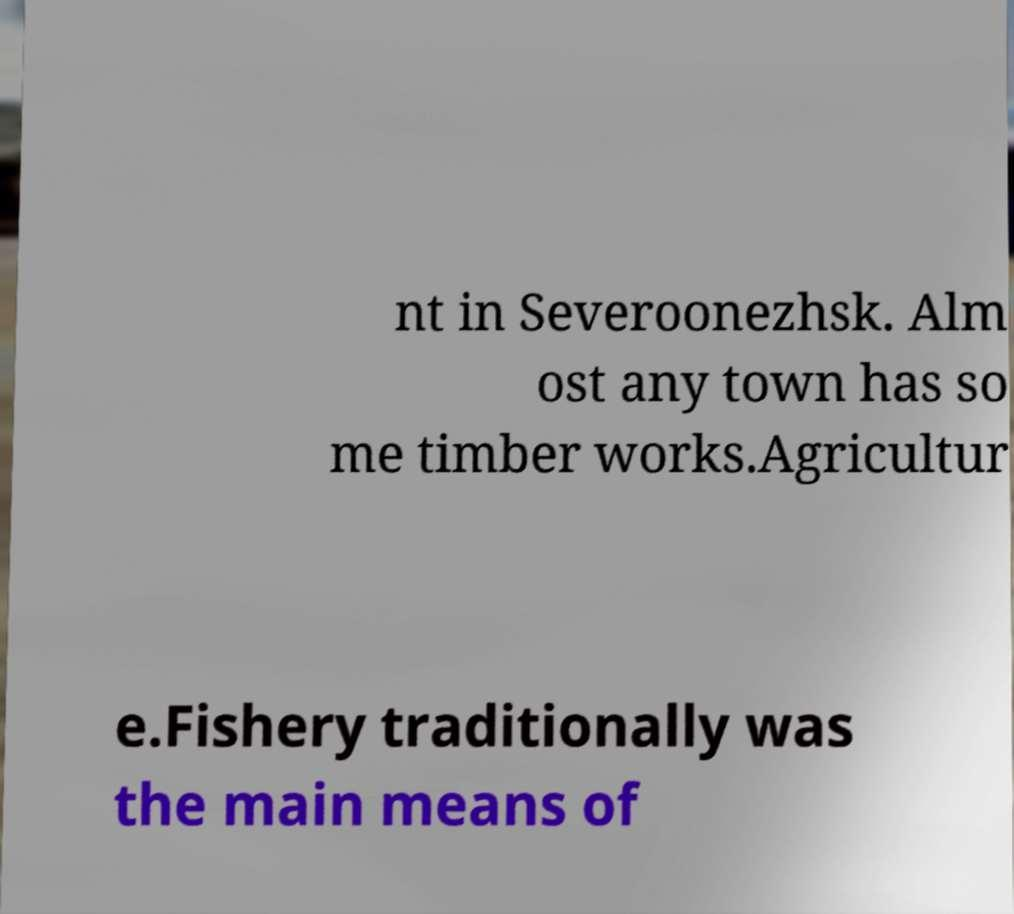For documentation purposes, I need the text within this image transcribed. Could you provide that? nt in Severoonezhsk. Alm ost any town has so me timber works.Agricultur e.Fishery traditionally was the main means of 